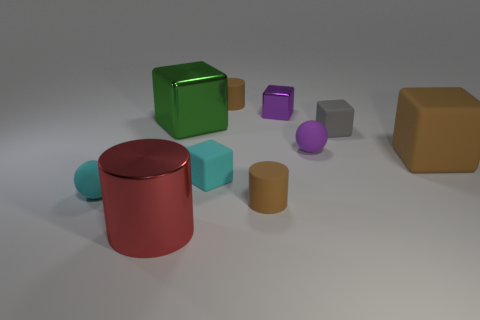Subtract all small purple cubes. How many cubes are left? 4 Subtract all red balls. How many brown cylinders are left? 2 Subtract all cylinders. How many objects are left? 7 Subtract all brown cubes. How many cubes are left? 4 Add 9 large brown objects. How many large brown objects are left? 10 Add 3 gray rubber blocks. How many gray rubber blocks exist? 4 Subtract 1 purple spheres. How many objects are left? 9 Subtract all yellow cylinders. Subtract all blue spheres. How many cylinders are left? 3 Subtract all small cyan blocks. Subtract all large blue things. How many objects are left? 9 